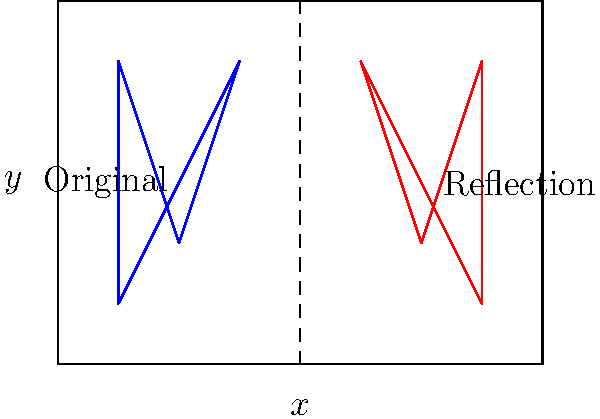The band's logo is represented by the blue shape in the diagram. If you reflect this logo across the line $x = 2$, which of the following statements is true about the reflected image (shown in red)?

A) It is congruent to the original logo
B) It is similar but not congruent to the original logo
C) It is neither similar nor congruent to the original logo
D) It is both similar and congruent to the original logo Let's analyze this step-by-step:

1) Reflection is an isometry, which means it preserves distances and angles.

2) Properties of reflection:
   a) The shape does not change size.
   b) The shape does not change orientation (it's not rotated).
   c) Each point of the original shape is the same distance from the line of reflection as its corresponding point in the reflected image.

3) In this case, we're reflecting across the line $x = 2$. This vertical line acts as a mirror.

4) Observe that:
   - The shape of the logo is preserved.
   - The size of the logo is unchanged.
   - The orientation is flipped but not rotated.

5) Congruence in geometry means that two shapes have the same size and shape.

6) Since reflection preserves both size and shape, the reflected image is congruent to the original logo.

Therefore, the reflected image is both similar (same shape) and congruent (same size and shape) to the original logo.
Answer: D 